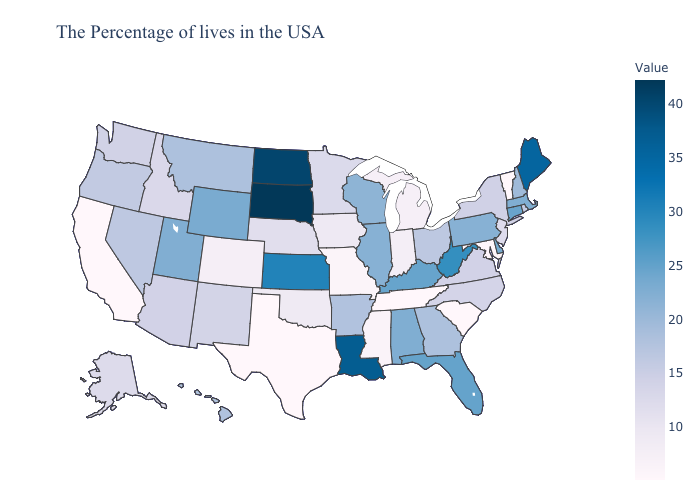Does New Mexico have a higher value than North Dakota?
Keep it brief. No. Among the states that border New York , which have the lowest value?
Answer briefly. Vermont. Which states have the lowest value in the West?
Short answer required. California. Does Nevada have a higher value than South Carolina?
Quick response, please. Yes. Among the states that border Iowa , does Missouri have the lowest value?
Concise answer only. Yes. Which states have the lowest value in the MidWest?
Answer briefly. Missouri. 